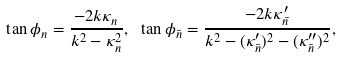<formula> <loc_0><loc_0><loc_500><loc_500>\tan \phi _ { n } = \frac { - 2 k \kappa _ { n } } { k ^ { 2 } - \kappa _ { n } ^ { 2 } } , \ \tan \phi _ { \bar { n } } = \frac { - 2 k \kappa ^ { \prime } _ { \bar { n } } } { k ^ { 2 } - ( \kappa _ { \bar { n } } ^ { \prime } ) ^ { 2 } - ( \kappa _ { \bar { n } } ^ { \prime \prime } ) ^ { 2 } } ,</formula> 